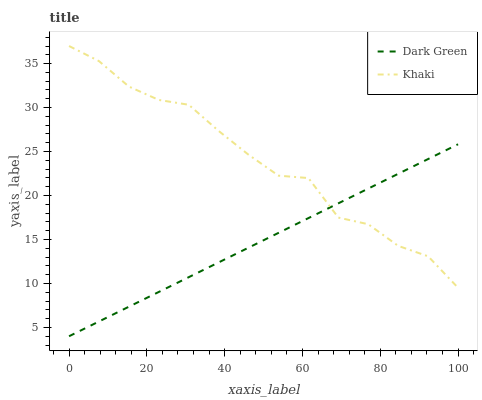Does Dark Green have the minimum area under the curve?
Answer yes or no. Yes. Does Khaki have the maximum area under the curve?
Answer yes or no. Yes. Does Dark Green have the maximum area under the curve?
Answer yes or no. No. Is Dark Green the smoothest?
Answer yes or no. Yes. Is Khaki the roughest?
Answer yes or no. Yes. Is Dark Green the roughest?
Answer yes or no. No. Does Dark Green have the lowest value?
Answer yes or no. Yes. Does Khaki have the highest value?
Answer yes or no. Yes. Does Dark Green have the highest value?
Answer yes or no. No. Does Dark Green intersect Khaki?
Answer yes or no. Yes. Is Dark Green less than Khaki?
Answer yes or no. No. Is Dark Green greater than Khaki?
Answer yes or no. No. 